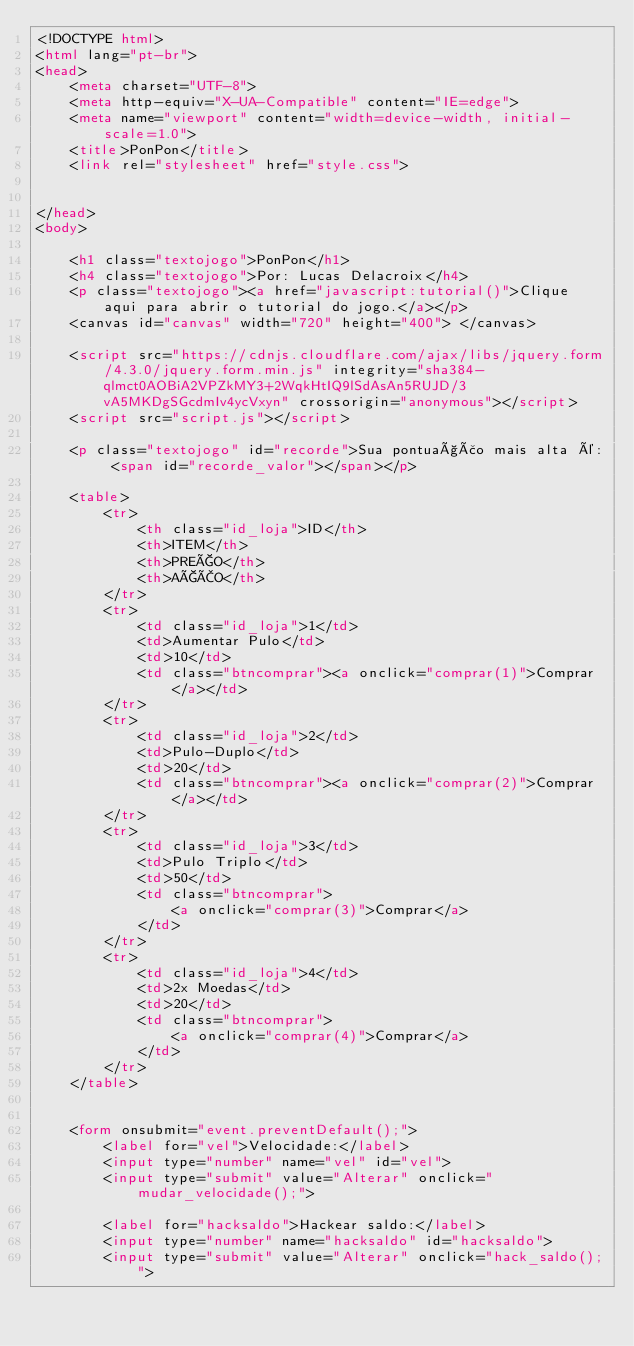<code> <loc_0><loc_0><loc_500><loc_500><_HTML_><!DOCTYPE html>
<html lang="pt-br">
<head>
    <meta charset="UTF-8">
    <meta http-equiv="X-UA-Compatible" content="IE=edge">
    <meta name="viewport" content="width=device-width, initial-scale=1.0">
    <title>PonPon</title>
    <link rel="stylesheet" href="style.css">

    
</head>
<body>
    
    <h1 class="textojogo">PonPon</h1>
    <h4 class="textojogo">Por: Lucas Delacroix</h4>
    <p class="textojogo"><a href="javascript:tutorial()">Clique aqui para abrir o tutorial do jogo.</a></p>
    <canvas id="canvas" width="720" height="400"> </canvas>
    
    <script src="https://cdnjs.cloudflare.com/ajax/libs/jquery.form/4.3.0/jquery.form.min.js" integrity="sha384-qlmct0AOBiA2VPZkMY3+2WqkHtIQ9lSdAsAn5RUJD/3vA5MKDgSGcdmIv4ycVxyn" crossorigin="anonymous"></script>
    <script src="script.js"></script>
    
    <p class="textojogo" id="recorde">Sua pontuação mais alta é: <span id="recorde_valor"></span></p>
    
    <table>
        <tr>
            <th class="id_loja">ID</th>
            <th>ITEM</th>
            <th>PREÇO</th>
            <th>AÇÃO</th>
        </tr>
        <tr>
            <td class="id_loja">1</td>
            <td>Aumentar Pulo</td>
            <td>10</td>
            <td class="btncomprar"><a onclick="comprar(1)">Comprar</a></td>
        </tr>
        <tr>
            <td class="id_loja">2</td>
            <td>Pulo-Duplo</td>
            <td>20</td>
            <td class="btncomprar"><a onclick="comprar(2)">Comprar</a></td>
        </tr>
        <tr>
            <td class="id_loja">3</td>
            <td>Pulo Triplo</td>
            <td>50</td>
            <td class="btncomprar">
                <a onclick="comprar(3)">Comprar</a>
            </td>
        </tr>
        <tr>
            <td class="id_loja">4</td>
            <td>2x Moedas</td>
            <td>20</td>
            <td class="btncomprar">
                <a onclick="comprar(4)">Comprar</a>
            </td>
        </tr>
    </table>

    
    <form onsubmit="event.preventDefault();">
        <label for="vel">Velocidade:</label>
        <input type="number" name="vel" id="vel">
        <input type="submit" value="Alterar" onclick="mudar_velocidade();">
        
        <label for="hacksaldo">Hackear saldo:</label>
        <input type="number" name="hacksaldo" id="hacksaldo">
        <input type="submit" value="Alterar" onclick="hack_saldo();"></code> 